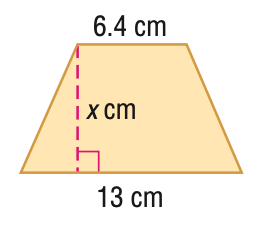Question: Find x. A = 78 cm^2.
Choices:
A. 6
B. 8.0
C. 11.5
D. 12.1
Answer with the letter. Answer: B 